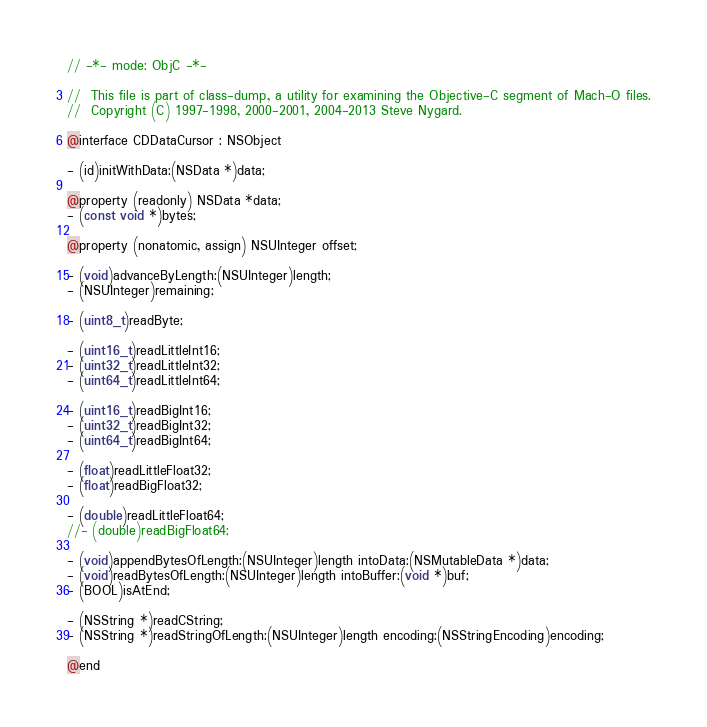<code> <loc_0><loc_0><loc_500><loc_500><_C_>// -*- mode: ObjC -*-

//  This file is part of class-dump, a utility for examining the Objective-C segment of Mach-O files.
//  Copyright (C) 1997-1998, 2000-2001, 2004-2013 Steve Nygard.

@interface CDDataCursor : NSObject

- (id)initWithData:(NSData *)data;

@property (readonly) NSData *data;
- (const void *)bytes;

@property (nonatomic, assign) NSUInteger offset;

- (void)advanceByLength:(NSUInteger)length;
- (NSUInteger)remaining;

- (uint8_t)readByte;

- (uint16_t)readLittleInt16;
- (uint32_t)readLittleInt32;
- (uint64_t)readLittleInt64;

- (uint16_t)readBigInt16;
- (uint32_t)readBigInt32;
- (uint64_t)readBigInt64;

- (float)readLittleFloat32;
- (float)readBigFloat32;

- (double)readLittleFloat64;
//- (double)readBigFloat64;

- (void)appendBytesOfLength:(NSUInteger)length intoData:(NSMutableData *)data;
- (void)readBytesOfLength:(NSUInteger)length intoBuffer:(void *)buf;
- (BOOL)isAtEnd;

- (NSString *)readCString;
- (NSString *)readStringOfLength:(NSUInteger)length encoding:(NSStringEncoding)encoding;

@end
</code> 